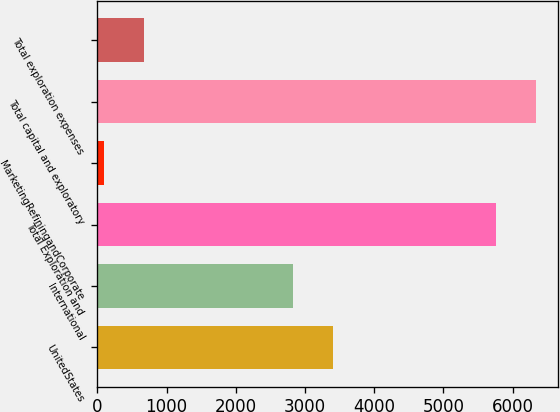<chart> <loc_0><loc_0><loc_500><loc_500><bar_chart><fcel>UnitedStates<fcel>International<fcel>Total Exploration and<fcel>MarketingRefiningandCorporate<fcel>Total capital and exploratory<fcel>Total exploration expenses<nl><fcel>3397.7<fcel>2822<fcel>5757<fcel>98<fcel>6332.7<fcel>673.7<nl></chart> 